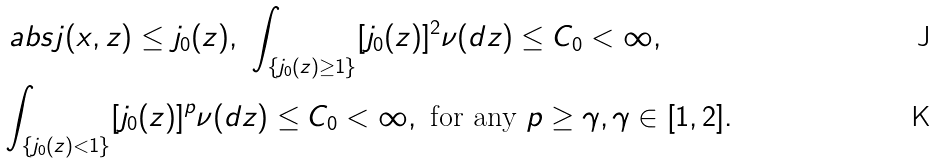Convert formula to latex. <formula><loc_0><loc_0><loc_500><loc_500>& \ a b s { j ( x , z ) } \leq j _ { 0 } ( z ) , \ \int _ { \{ j _ { 0 } ( z ) \geq 1 \} } [ j _ { 0 } ( z ) ] ^ { 2 } \nu ( d z ) \leq C _ { 0 } < \infty , \\ & \int _ { \{ j _ { 0 } ( z ) < 1 \} } [ j _ { 0 } ( z ) ] ^ { p } \nu ( d z ) \leq C _ { 0 } < \infty , \ \text {for any} \ p \geq \gamma , \gamma \in [ 1 , 2 ] .</formula> 